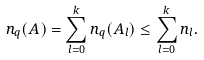Convert formula to latex. <formula><loc_0><loc_0><loc_500><loc_500>n _ { q } ( A ) = \sum _ { l = 0 } ^ { k } n _ { q } ( A _ { l } ) \leq \sum _ { l = 0 } ^ { k } n _ { l } .</formula> 